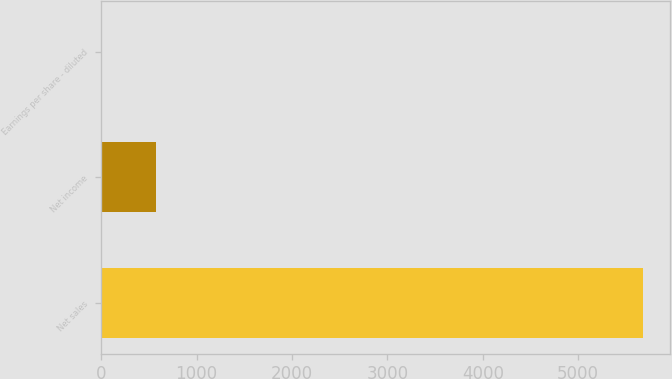Convert chart. <chart><loc_0><loc_0><loc_500><loc_500><bar_chart><fcel>Net sales<fcel>Net income<fcel>Earnings per share - diluted<nl><fcel>5682<fcel>568.34<fcel>0.15<nl></chart> 